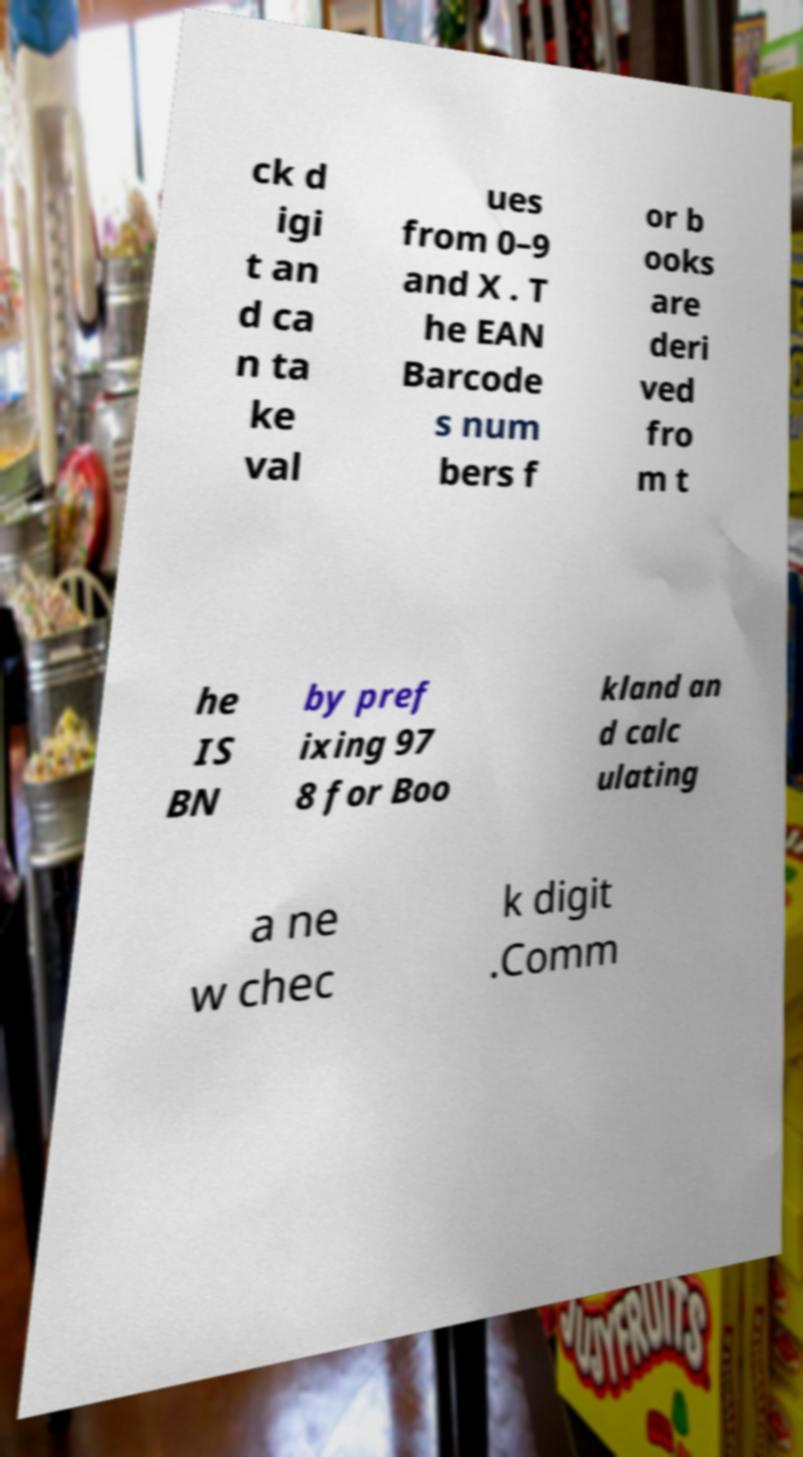Please identify and transcribe the text found in this image. ck d igi t an d ca n ta ke val ues from 0–9 and X . T he EAN Barcode s num bers f or b ooks are deri ved fro m t he IS BN by pref ixing 97 8 for Boo kland an d calc ulating a ne w chec k digit .Comm 